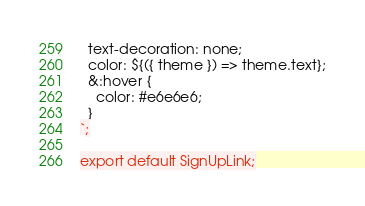<code> <loc_0><loc_0><loc_500><loc_500><_JavaScript_>  text-decoration: none;
  color: ${({ theme }) => theme.text};
  &:hover {
    color: #e6e6e6;
  }
`;

export default SignUpLink;
</code> 